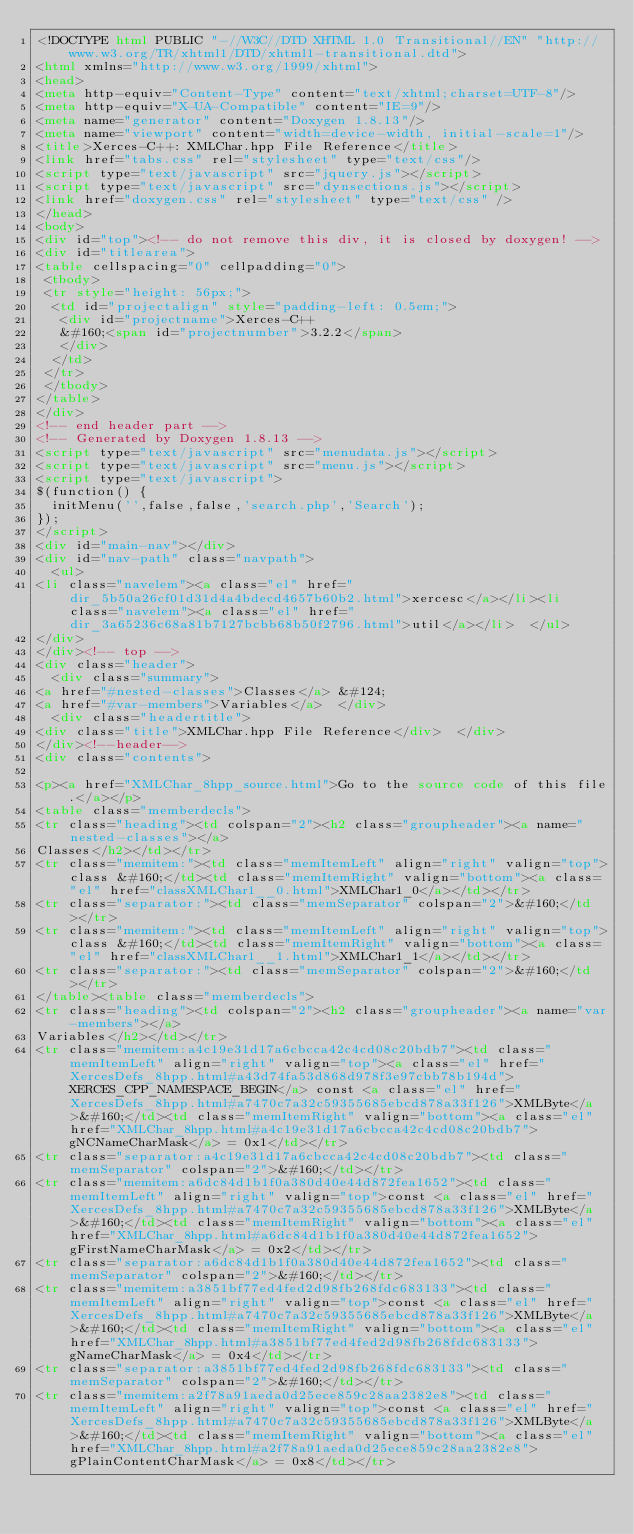Convert code to text. <code><loc_0><loc_0><loc_500><loc_500><_HTML_><!DOCTYPE html PUBLIC "-//W3C//DTD XHTML 1.0 Transitional//EN" "http://www.w3.org/TR/xhtml1/DTD/xhtml1-transitional.dtd">
<html xmlns="http://www.w3.org/1999/xhtml">
<head>
<meta http-equiv="Content-Type" content="text/xhtml;charset=UTF-8"/>
<meta http-equiv="X-UA-Compatible" content="IE=9"/>
<meta name="generator" content="Doxygen 1.8.13"/>
<meta name="viewport" content="width=device-width, initial-scale=1"/>
<title>Xerces-C++: XMLChar.hpp File Reference</title>
<link href="tabs.css" rel="stylesheet" type="text/css"/>
<script type="text/javascript" src="jquery.js"></script>
<script type="text/javascript" src="dynsections.js"></script>
<link href="doxygen.css" rel="stylesheet" type="text/css" />
</head>
<body>
<div id="top"><!-- do not remove this div, it is closed by doxygen! -->
<div id="titlearea">
<table cellspacing="0" cellpadding="0">
 <tbody>
 <tr style="height: 56px;">
  <td id="projectalign" style="padding-left: 0.5em;">
   <div id="projectname">Xerces-C++
   &#160;<span id="projectnumber">3.2.2</span>
   </div>
  </td>
 </tr>
 </tbody>
</table>
</div>
<!-- end header part -->
<!-- Generated by Doxygen 1.8.13 -->
<script type="text/javascript" src="menudata.js"></script>
<script type="text/javascript" src="menu.js"></script>
<script type="text/javascript">
$(function() {
  initMenu('',false,false,'search.php','Search');
});
</script>
<div id="main-nav"></div>
<div id="nav-path" class="navpath">
  <ul>
<li class="navelem"><a class="el" href="dir_5b50a26cf01d31d4a4bdecd4657b60b2.html">xercesc</a></li><li class="navelem"><a class="el" href="dir_3a65236c68a81b7127bcbb68b50f2796.html">util</a></li>  </ul>
</div>
</div><!-- top -->
<div class="header">
  <div class="summary">
<a href="#nested-classes">Classes</a> &#124;
<a href="#var-members">Variables</a>  </div>
  <div class="headertitle">
<div class="title">XMLChar.hpp File Reference</div>  </div>
</div><!--header-->
<div class="contents">

<p><a href="XMLChar_8hpp_source.html">Go to the source code of this file.</a></p>
<table class="memberdecls">
<tr class="heading"><td colspan="2"><h2 class="groupheader"><a name="nested-classes"></a>
Classes</h2></td></tr>
<tr class="memitem:"><td class="memItemLeft" align="right" valign="top">class &#160;</td><td class="memItemRight" valign="bottom"><a class="el" href="classXMLChar1__0.html">XMLChar1_0</a></td></tr>
<tr class="separator:"><td class="memSeparator" colspan="2">&#160;</td></tr>
<tr class="memitem:"><td class="memItemLeft" align="right" valign="top">class &#160;</td><td class="memItemRight" valign="bottom"><a class="el" href="classXMLChar1__1.html">XMLChar1_1</a></td></tr>
<tr class="separator:"><td class="memSeparator" colspan="2">&#160;</td></tr>
</table><table class="memberdecls">
<tr class="heading"><td colspan="2"><h2 class="groupheader"><a name="var-members"></a>
Variables</h2></td></tr>
<tr class="memitem:a4c19e31d17a6cbcca42c4cd08c20bdb7"><td class="memItemLeft" align="right" valign="top"><a class="el" href="XercesDefs_8hpp.html#a43d74fa53d868d978f3e97cbb78b194d">XERCES_CPP_NAMESPACE_BEGIN</a> const <a class="el" href="XercesDefs_8hpp.html#a7470c7a32c59355685ebcd878a33f126">XMLByte</a>&#160;</td><td class="memItemRight" valign="bottom"><a class="el" href="XMLChar_8hpp.html#a4c19e31d17a6cbcca42c4cd08c20bdb7">gNCNameCharMask</a> = 0x1</td></tr>
<tr class="separator:a4c19e31d17a6cbcca42c4cd08c20bdb7"><td class="memSeparator" colspan="2">&#160;</td></tr>
<tr class="memitem:a6dc84d1b1f0a380d40e44d872fea1652"><td class="memItemLeft" align="right" valign="top">const <a class="el" href="XercesDefs_8hpp.html#a7470c7a32c59355685ebcd878a33f126">XMLByte</a>&#160;</td><td class="memItemRight" valign="bottom"><a class="el" href="XMLChar_8hpp.html#a6dc84d1b1f0a380d40e44d872fea1652">gFirstNameCharMask</a> = 0x2</td></tr>
<tr class="separator:a6dc84d1b1f0a380d40e44d872fea1652"><td class="memSeparator" colspan="2">&#160;</td></tr>
<tr class="memitem:a3851bf77ed4fed2d98fb268fdc683133"><td class="memItemLeft" align="right" valign="top">const <a class="el" href="XercesDefs_8hpp.html#a7470c7a32c59355685ebcd878a33f126">XMLByte</a>&#160;</td><td class="memItemRight" valign="bottom"><a class="el" href="XMLChar_8hpp.html#a3851bf77ed4fed2d98fb268fdc683133">gNameCharMask</a> = 0x4</td></tr>
<tr class="separator:a3851bf77ed4fed2d98fb268fdc683133"><td class="memSeparator" colspan="2">&#160;</td></tr>
<tr class="memitem:a2f78a91aeda0d25ece859c28aa2382e8"><td class="memItemLeft" align="right" valign="top">const <a class="el" href="XercesDefs_8hpp.html#a7470c7a32c59355685ebcd878a33f126">XMLByte</a>&#160;</td><td class="memItemRight" valign="bottom"><a class="el" href="XMLChar_8hpp.html#a2f78a91aeda0d25ece859c28aa2382e8">gPlainContentCharMask</a> = 0x8</td></tr></code> 